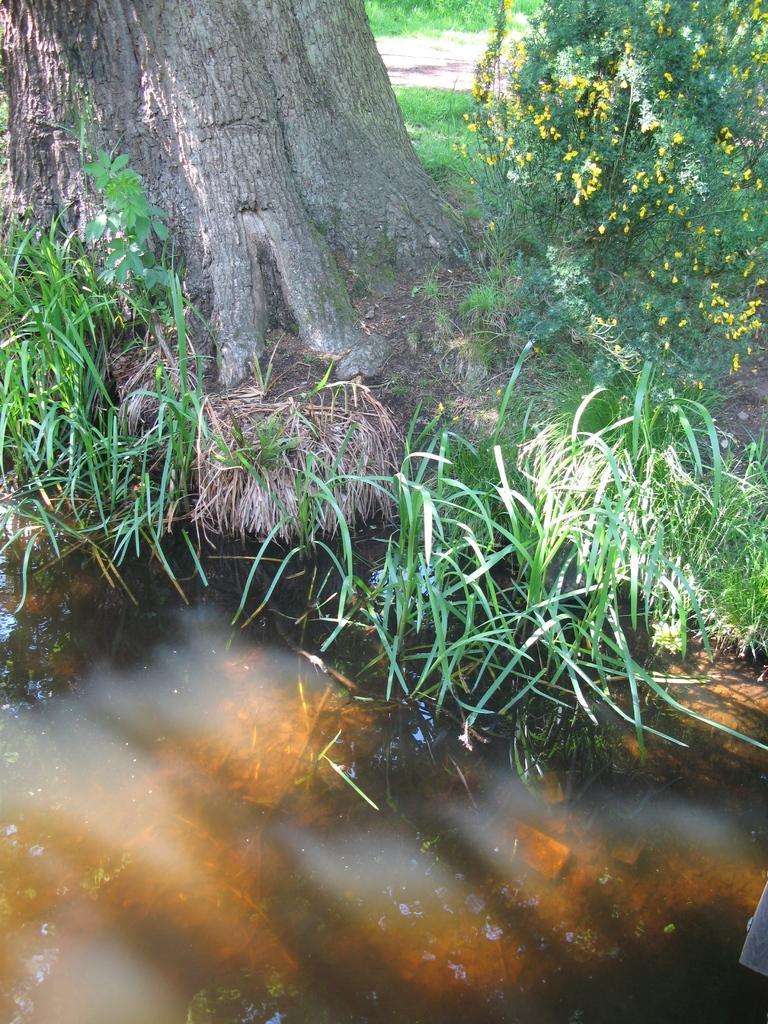Could you give a brief overview of what you see in this image? In this image there is water at the bottom. At the top there is a tree trunk. There is grass beside the water. On the right side top there are plants with small yellow color flowers. In the background there is a way. 